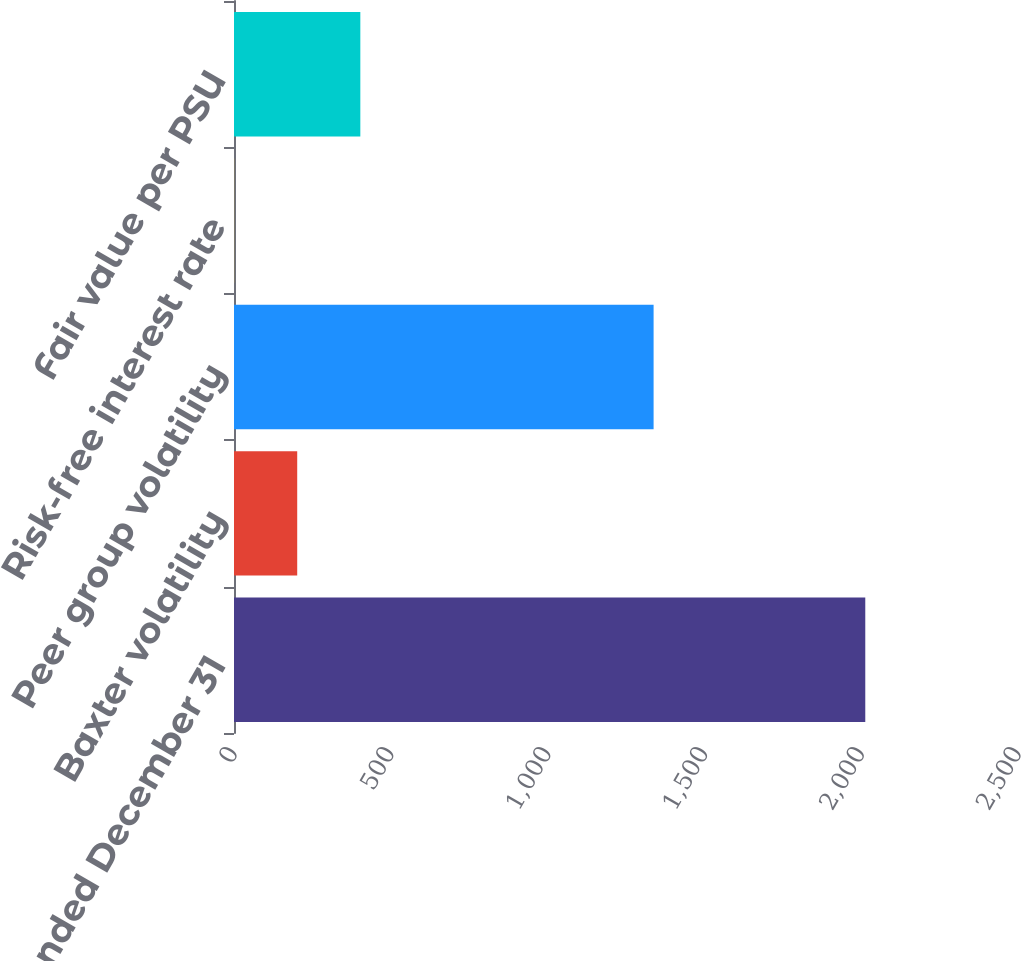Convert chart to OTSL. <chart><loc_0><loc_0><loc_500><loc_500><bar_chart><fcel>years ended December 31<fcel>Baxter volatility<fcel>Peer group volatility<fcel>Risk-free interest rate<fcel>Fair value per PSU<nl><fcel>2013<fcel>201.57<fcel>1338<fcel>0.3<fcel>402.84<nl></chart> 